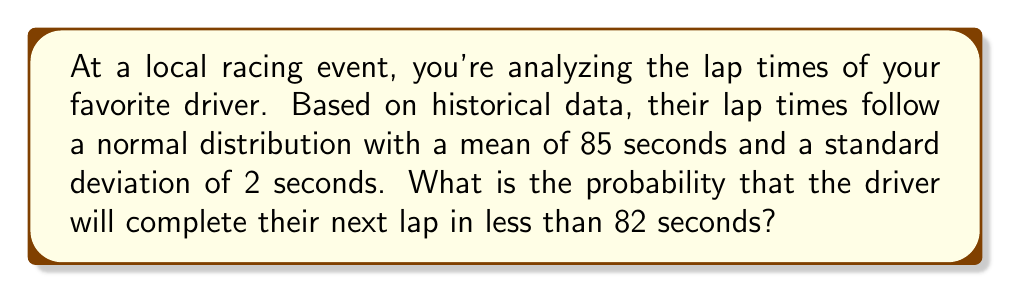Could you help me with this problem? To solve this problem, we'll use the properties of the normal distribution and the concept of z-scores. Let's break it down step-by-step:

1. We're given:
   - Mean lap time (μ) = 85 seconds
   - Standard deviation (σ) = 2 seconds
   - We want to find P(X < 82), where X is the lap time

2. Calculate the z-score for 82 seconds:
   $$ z = \frac{x - \mu}{\sigma} = \frac{82 - 85}{2} = -1.5 $$

3. The z-score of -1.5 represents how many standard deviations 82 seconds is below the mean.

4. To find the probability, we need to use a standard normal distribution table or a calculator function. We're looking for the area to the left of z = -1.5.

5. Using a standard normal distribution table or calculator:
   $$ P(Z < -1.5) \approx 0.0668 $$

6. Therefore, the probability of the driver completing the next lap in less than 82 seconds is approximately 0.0668 or 6.68%.

This analysis helps racing fans understand the likelihood of specific lap times occurring based on a driver's historical performance.
Answer: 0.0668 (or 6.68%) 